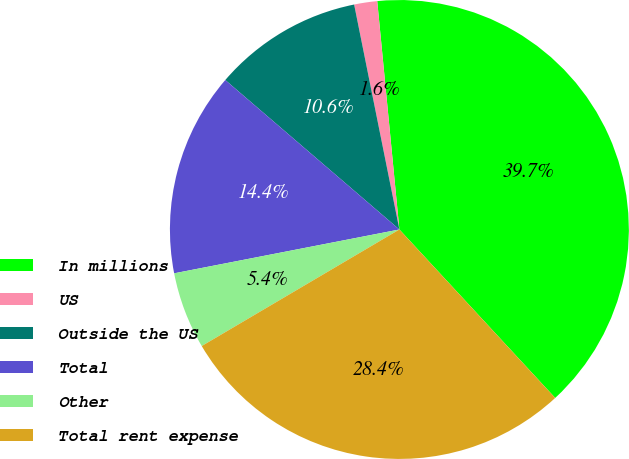Convert chart. <chart><loc_0><loc_0><loc_500><loc_500><pie_chart><fcel>In millions<fcel>US<fcel>Outside the US<fcel>Total<fcel>Other<fcel>Total rent expense<nl><fcel>39.66%<fcel>1.62%<fcel>10.55%<fcel>14.35%<fcel>5.42%<fcel>28.4%<nl></chart> 